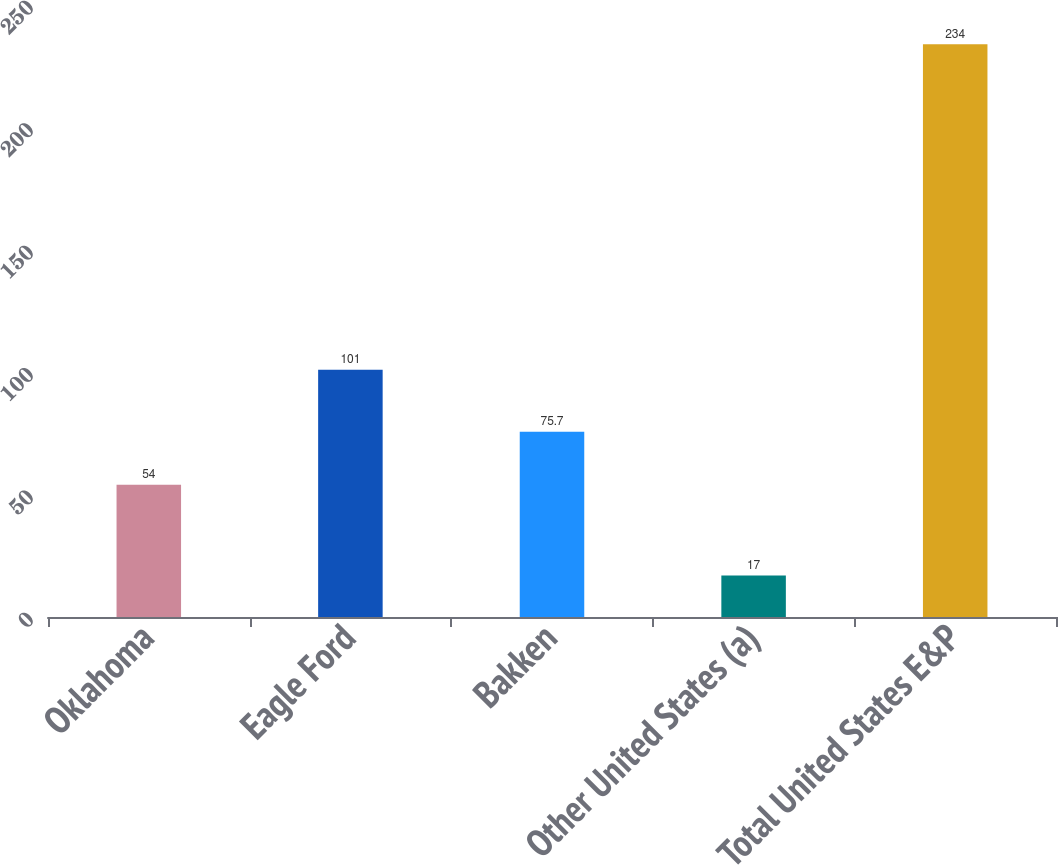Convert chart. <chart><loc_0><loc_0><loc_500><loc_500><bar_chart><fcel>Oklahoma<fcel>Eagle Ford<fcel>Bakken<fcel>Other United States (a)<fcel>Total United States E&P<nl><fcel>54<fcel>101<fcel>75.7<fcel>17<fcel>234<nl></chart> 